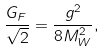Convert formula to latex. <formula><loc_0><loc_0><loc_500><loc_500>\frac { G _ { F } } { \sqrt { 2 } } = \frac { g ^ { 2 } } { 8 M ^ { 2 } _ { W } } ,</formula> 